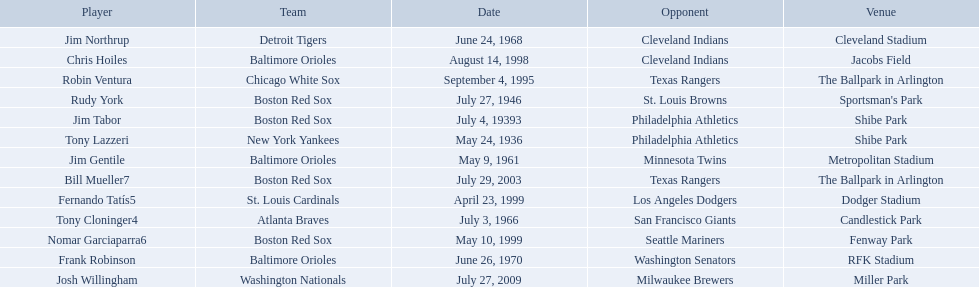Who are the opponents of the boston red sox during baseball home run records? Philadelphia Athletics, St. Louis Browns, Seattle Mariners, Texas Rangers. Of those which was the opponent on july 27, 1946? St. Louis Browns. What were the dates of each game? May 24, 1936, July 4, 19393, July 27, 1946, May 9, 1961, July 3, 1966, June 24, 1968, June 26, 1970, September 4, 1995, August 14, 1998, April 23, 1999, May 10, 1999, July 29, 2003, July 27, 2009. Who were all of the teams? New York Yankees, Boston Red Sox, Boston Red Sox, Baltimore Orioles, Atlanta Braves, Detroit Tigers, Baltimore Orioles, Chicago White Sox, Baltimore Orioles, St. Louis Cardinals, Boston Red Sox, Boston Red Sox, Washington Nationals. What about their opponents? Philadelphia Athletics, Philadelphia Athletics, St. Louis Browns, Minnesota Twins, San Francisco Giants, Cleveland Indians, Washington Senators, Texas Rangers, Cleveland Indians, Los Angeles Dodgers, Seattle Mariners, Texas Rangers, Milwaukee Brewers. And on which date did the detroit tigers play against the cleveland indians? June 24, 1968. 